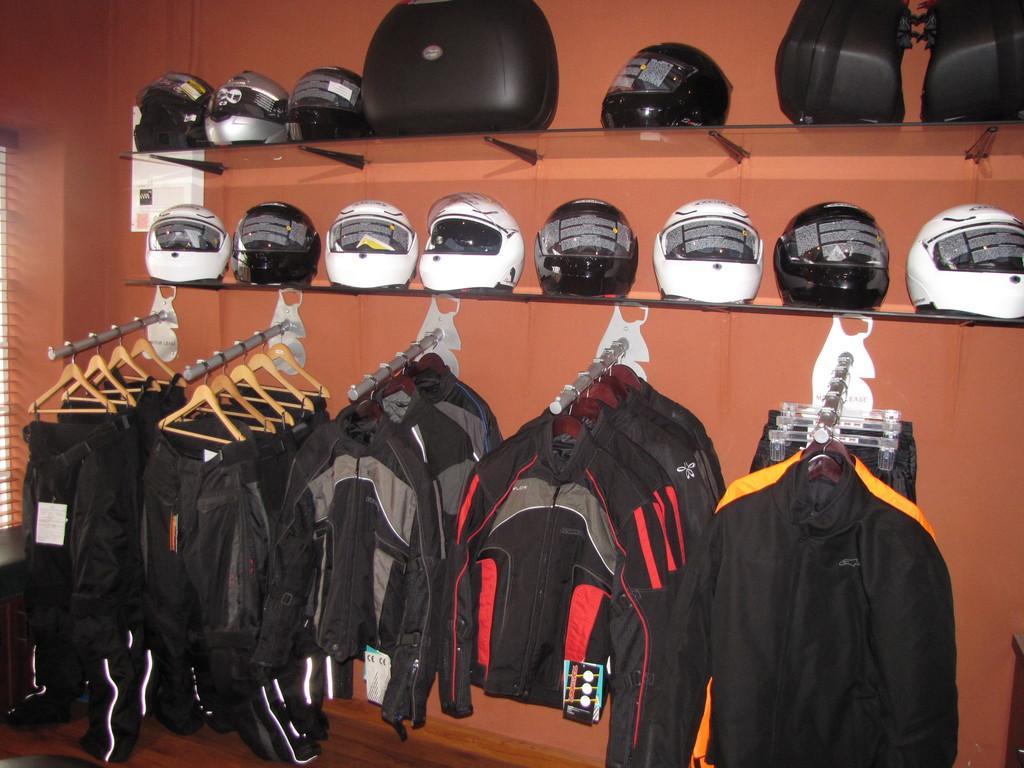Describe this image in one or two sentences. In this picture we can see some clothes and hangers in the front, in the background there is a wall, there are two shelves in the middle, we can see helmets on these shelves. 